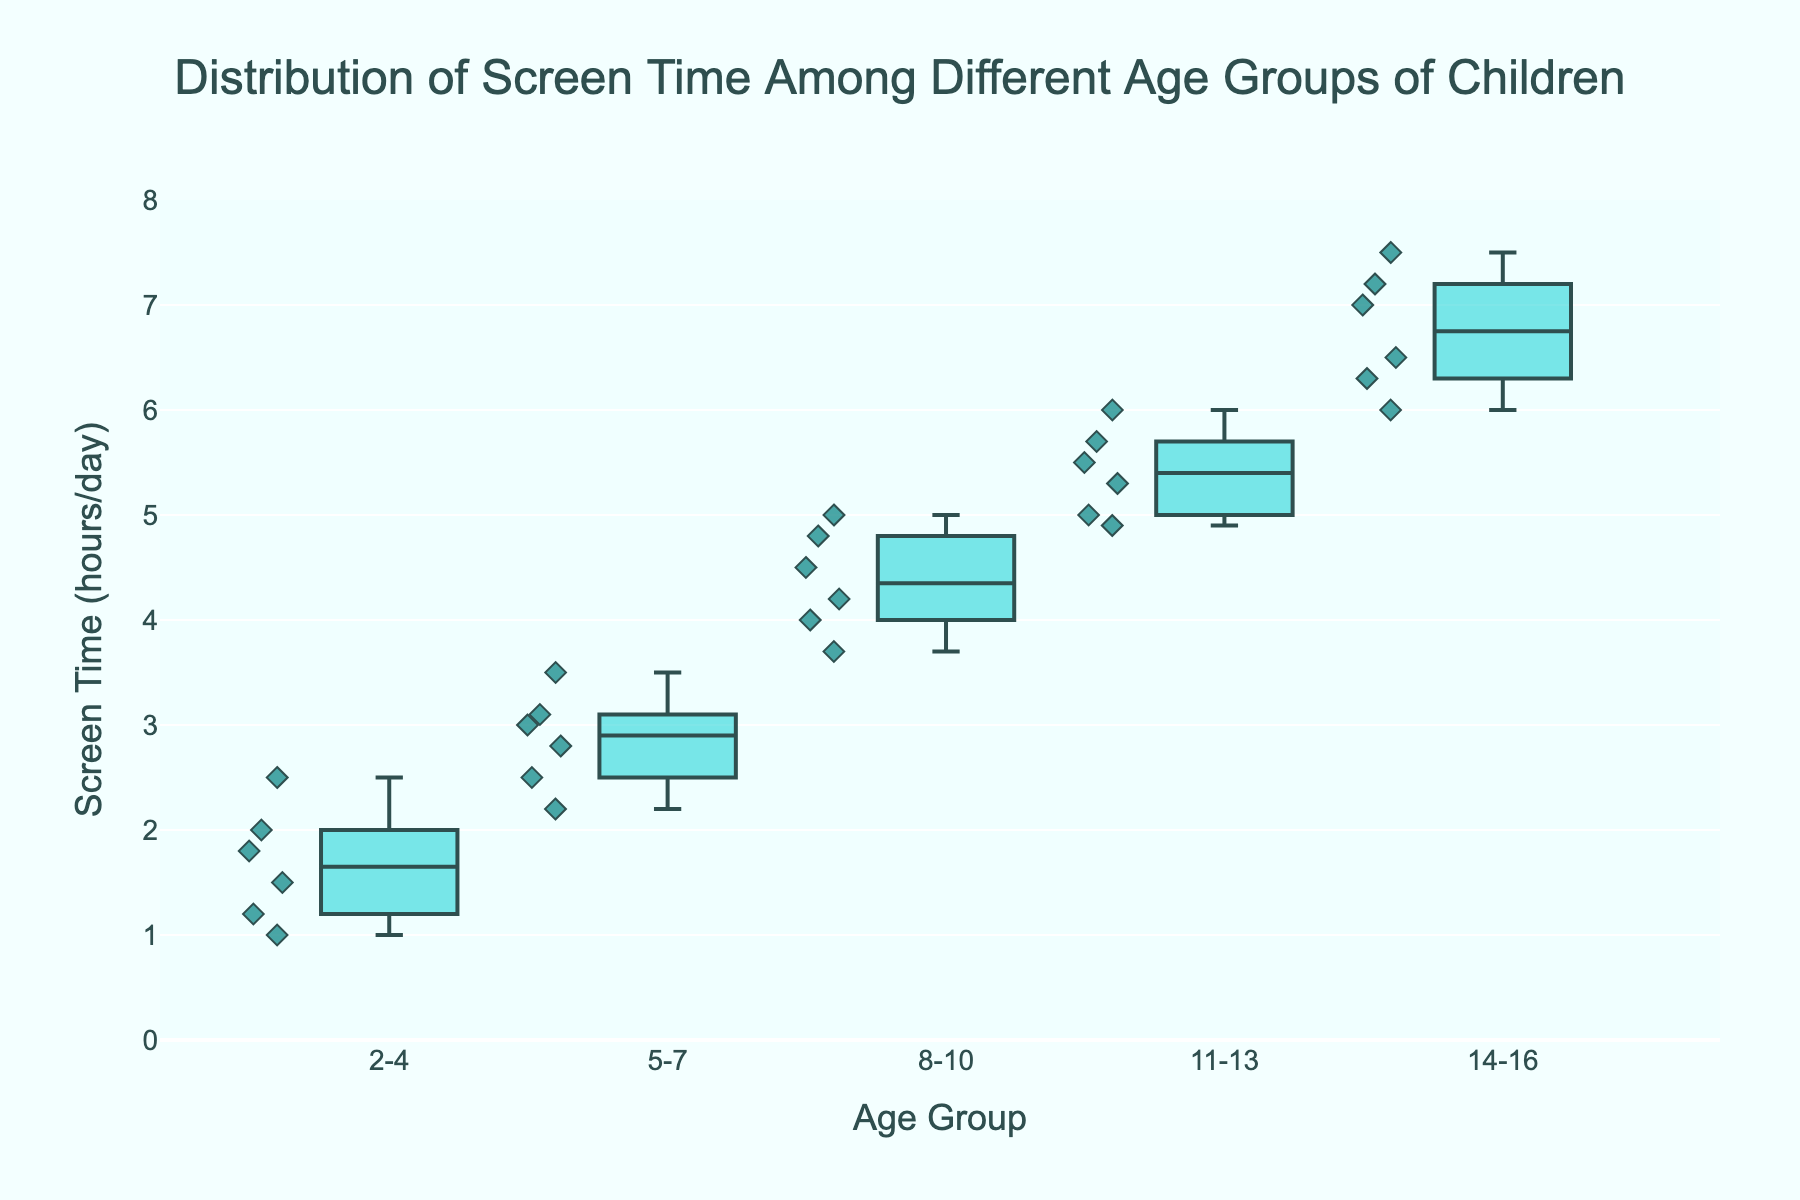What's the title of the figure? The title is typically displayed at the top of the figure. It provides an overview of what the figure is about.
Answer: Distribution of Screen Time Among Different Age Groups of Children What’s the screen time range for the '2-4' age group? The screen time range can be determined by looking at the lowest and highest points (whiskers) of the box plot for that group.
Answer: 1 to 2.5 hours/day Which age group has the highest median screen time? The median screen time is represented by the line inside each box. From the boxes, identify the highest median line.
Answer: 14-16 What’s the median screen time for the '8-10' age group? Look at the line inside the box for '8-10'. The median is where the line inside the box is located.
Answer: 4.4 hours/day Which age group has the smallest interquartile range (IQR) for screen time? The IQR is the box's height, representing the difference between the 25th and 75th percentiles. Find the smallest box.
Answer: 2-4 How does the screen time of the '5-7' age group compare to the '11-13' age group in terms of the median? Compare the median lines within the boxes of ‘5-7’ and ‘11-13’. The position of the line gives this comparison.
Answer: '11-13' has a higher median screen time What is the interquartile range (IQR) for the '14-16' age group? Determine the height of the box, calculated as Q3 (upper quartile) - Q1 (lower quartile).
Answer: 7 - 6.3 = 0.7 hours/day Which age group shows the most variability in screen time? Variability is indicated by the length of the whiskers and the spread of the data points within each box plot. Identify the age group with the widest spread.
Answer: 14-16 